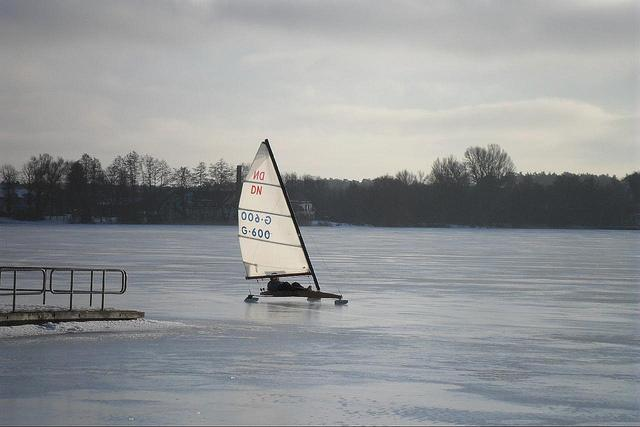In which manner does this vehicle move? wind 